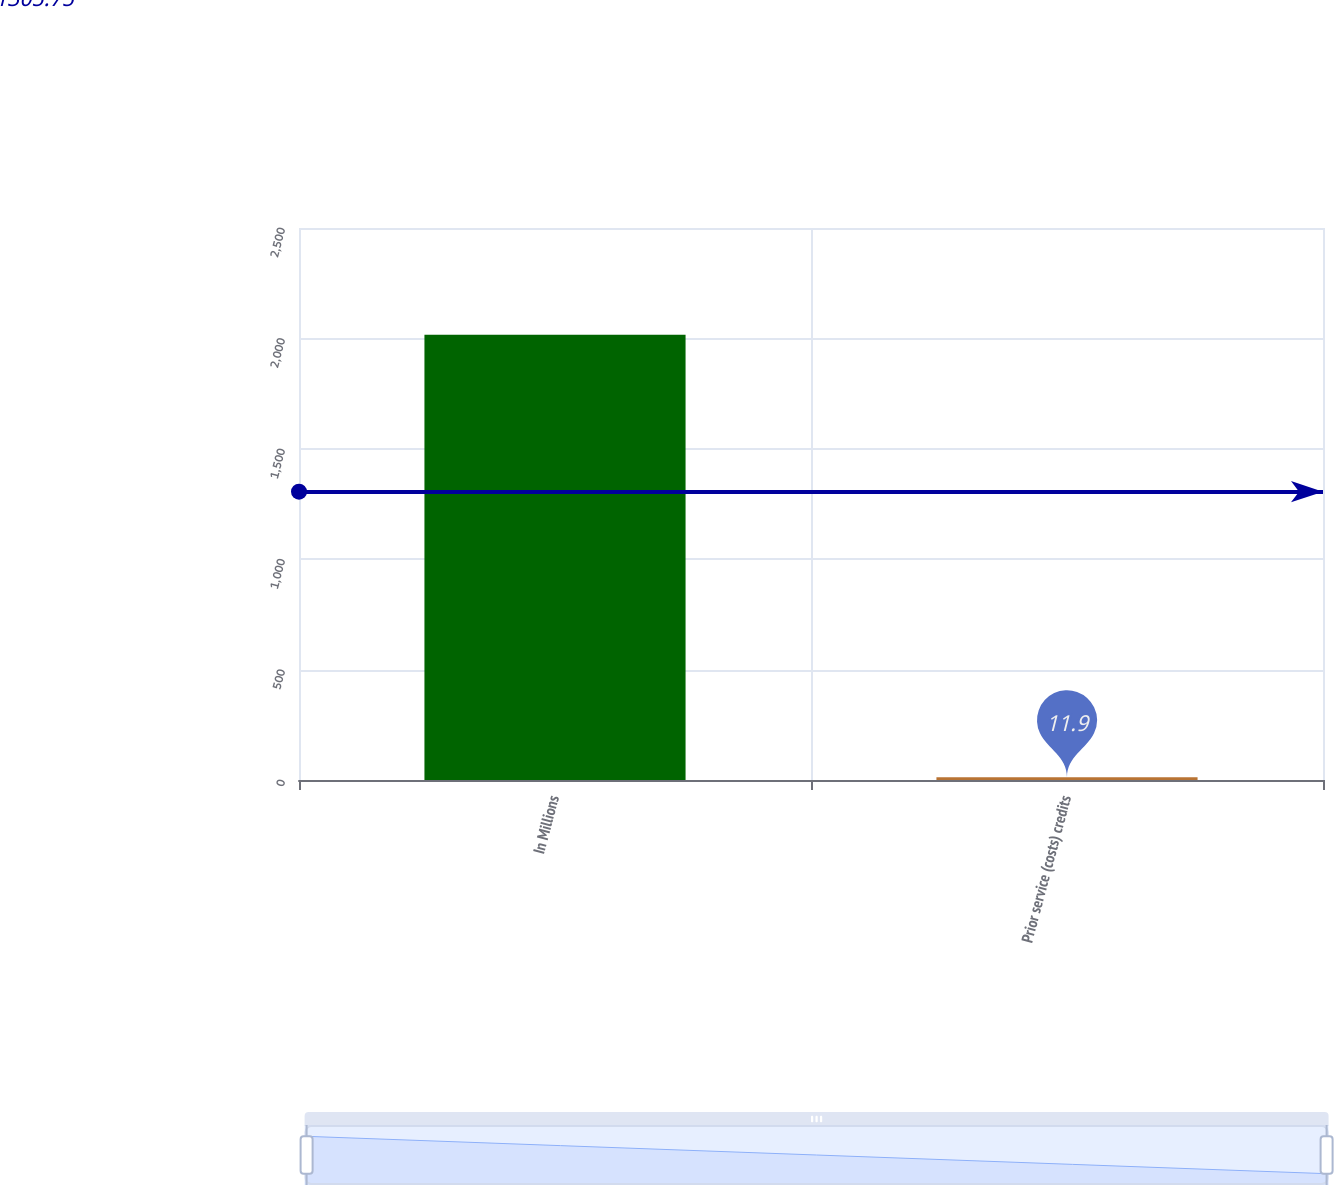<chart> <loc_0><loc_0><loc_500><loc_500><bar_chart><fcel>In Millions<fcel>Prior service (costs) credits<nl><fcel>2016<fcel>11.9<nl></chart> 